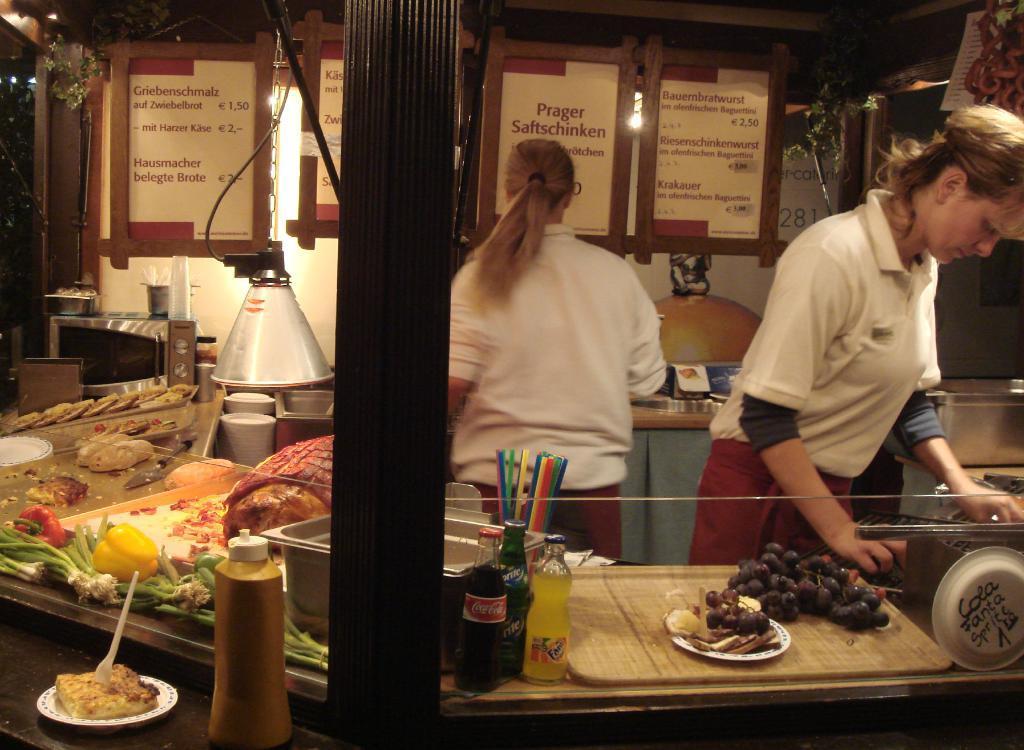How would you summarize this image in a sentence or two? In this picture I can see there are two women standing and they are wearing white shirts. There is some food placed on the trays and there are bell peppers, spring onions and some other food. There are lights, menu cards attached to the ceiling. There is some food in the plate with a fork and there is a sauce bottle. 